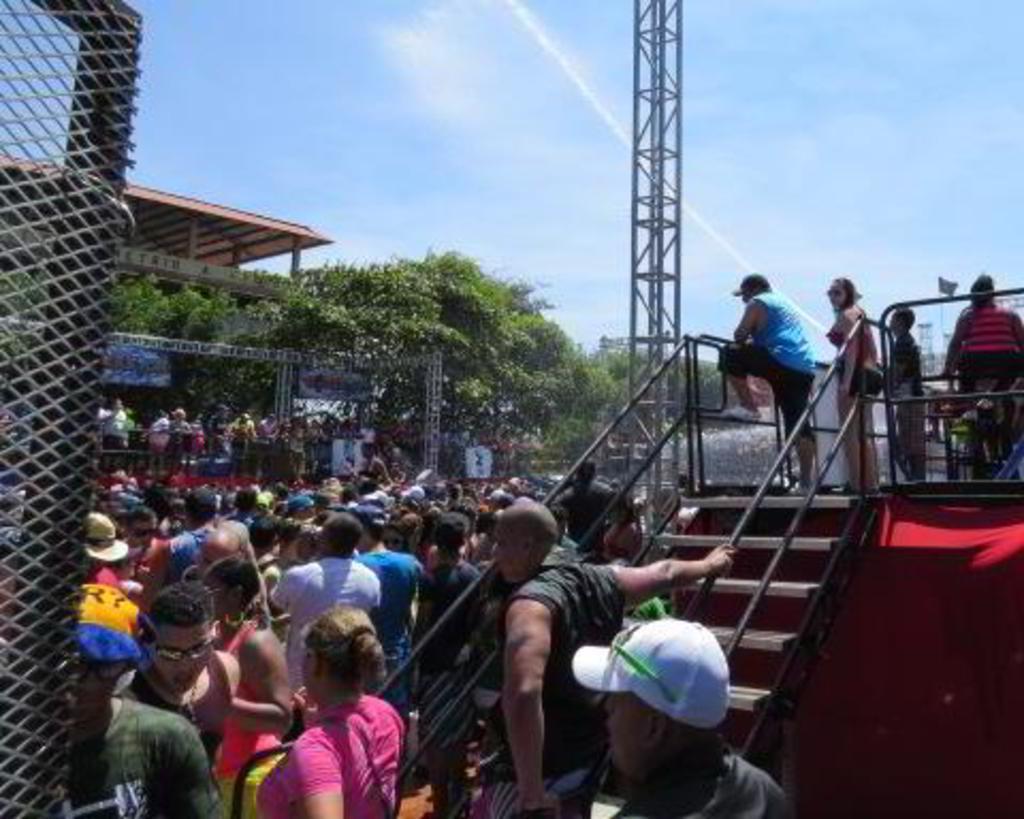Could you give a brief overview of what you see in this image? There are people, staircase, stage and a mesh in the foreground area of the image, there are trees, people, tower, roof and the sky in the background. 